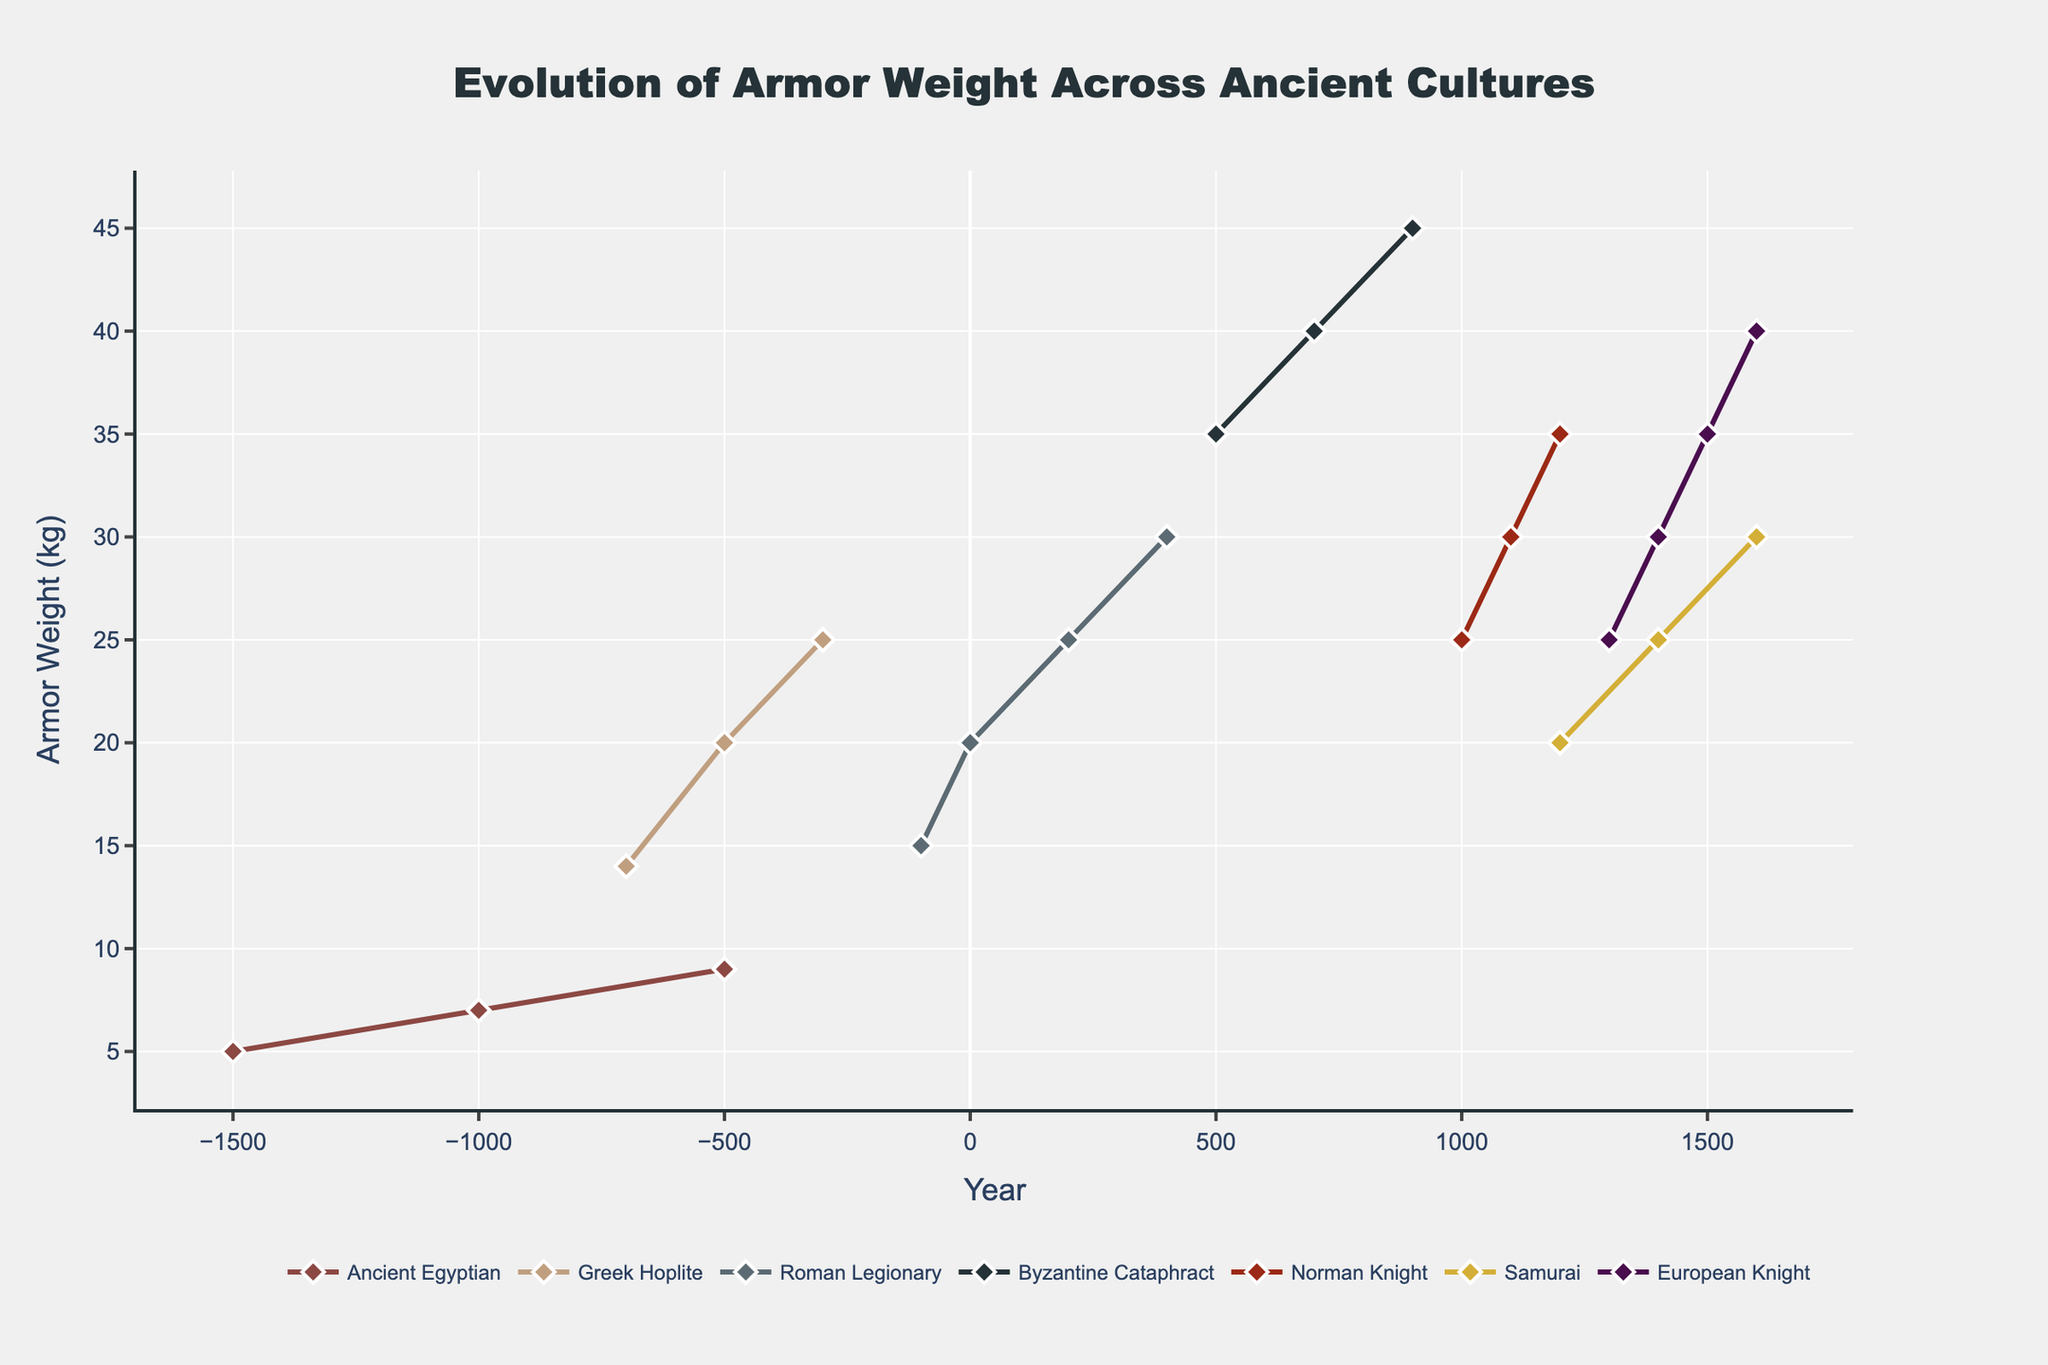Which culture had the heaviest armor in the year 900? To find the heaviest armor for the year 900, we identify the data points for each culture at this specific year. The Byzantine Cataphract had a weight of 45 kg in 900, which is the highest.
Answer: Byzantine Cataphract Which ancient culture's armor weight increased the most between 1000 and 1200? To determine the culture with the most significant increase between 1000 and 1200, we compare the weights for all cultures in these years. The Norman Knight’s armor increased from 25 kg in 1000 to 35 kg in 1200, which is a 10 kg increase.
Answer: Norman Knight What is the difference in armor weight between the Roman Legionary and the European Knight in the year 1300? Look at the weights for both cultures in the year 1300. The Roman Legionary data is not available for 1300, the closest available data is 400 with 30 kg, whereas the European Knight had 25 kg in 1300. The closest comparison shows a 5 kg difference.
Answer: 5 Which culture had the lightest armor in the year 1500? Check the data points for all available cultures in the year 1500. The European Knight's armor weight in 1500 was 35 kg. Other data closer to this year is the Samurai armor in 1400 with 25 kg, making Samurai the lightest around this period.
Answer: Samurai Did the armor weight of the Ancient Egyptian culture show a consistent increase over time? Review the data points for the Ancient Egyptian culture (-1500, -1000, and -500). The weights are 5 kg, 7 kg, and 9 kg respectively, showing a consistent increase over time.
Answer: Yes What was the average weight of the Byzantine Cataphract's armor over the years 500, 700, and 900? Calculate the average by summing the weights (35 kg, 40 kg, and 45 kg) and dividing by the number of data points (3). Average = (35 + 40 + 45) / 3 = 40 kg.
Answer: 40 How did the weight of the Samurai armor change between 1200 and 1600? Compare the weights of the Samurai armor between 1200 and 1600. In 1200, the weight was 20 kg, and in 1600, it was 30 kg. The difference is 30 kg - 20 kg = 10 kg.
Answer: 10 kg increase 